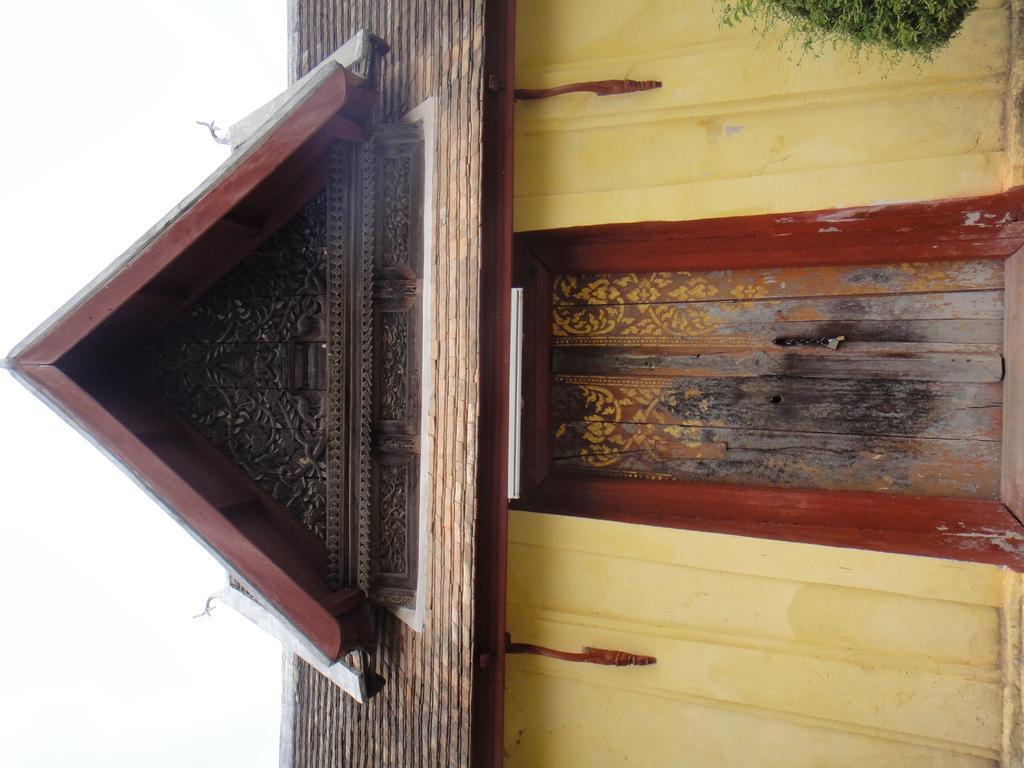How would you summarize this image in a sentence or two? In the picture there is a house and there are some designs made on the roof of the house. 